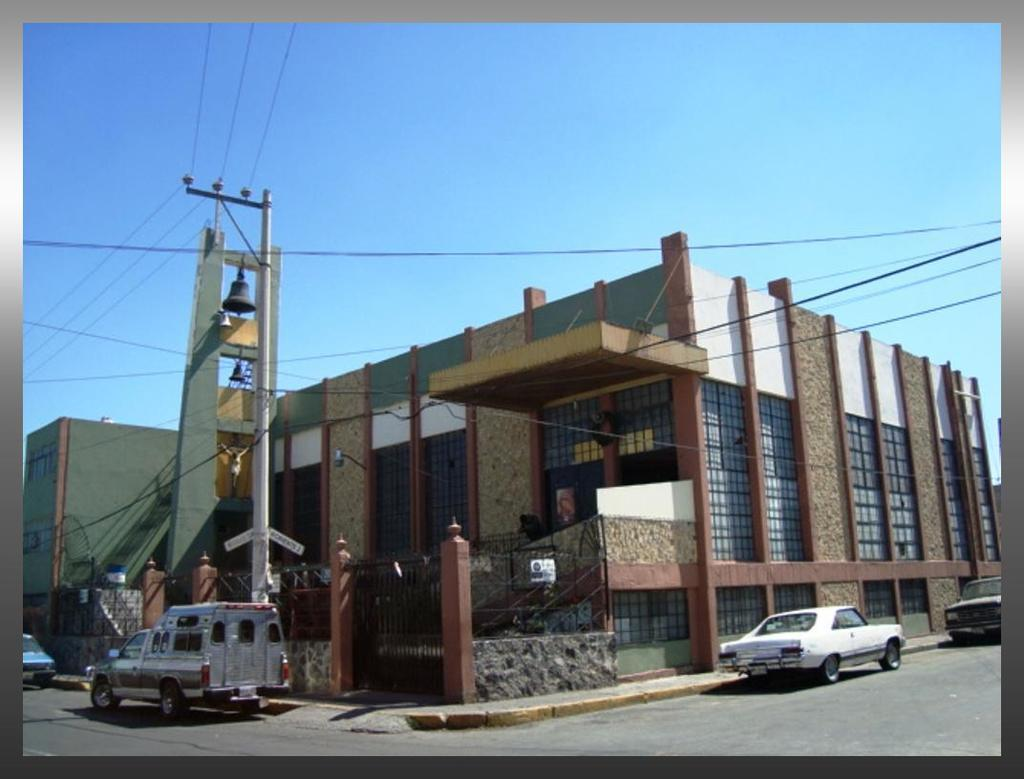What can be seen on the road in the image? There are vehicles on the road in the image. What is located near the road? There is a current pole and wires present in the image. What objects are hanging from the wires? Bells are visible in the image. What type of structure is in the image? There is a statue and a building in the image. What architectural features can be seen in the image? There is a gate and a fence present in the image. What else is visible in the image? Boards are visible in the image. What can be seen in the background of the image? The sky is visible in the background of the image. What type of brain is visible in the image? There is no brain present in the image. What type of celery can be seen growing near the statue? There is no celery present in the image. 